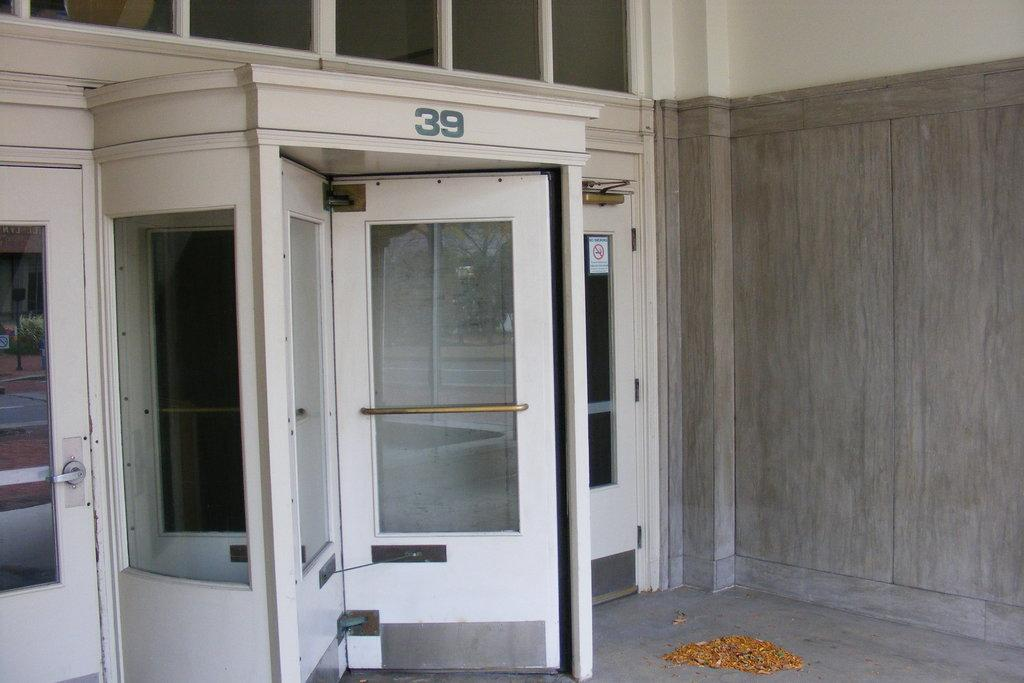<image>
Summarize the visual content of the image. White rotating doors leading into a building have the number 39 displayed above them 